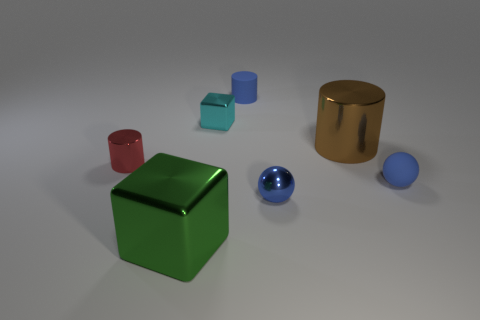What is the color of the tiny cylinder that is right of the block in front of the tiny metal sphere?
Offer a very short reply. Blue. What is the material of the blue object that is behind the small shiny cylinder?
Ensure brevity in your answer.  Rubber. Is the number of big gray matte balls less than the number of small red metallic cylinders?
Offer a terse response. Yes. There is a cyan thing; is its shape the same as the small blue thing that is behind the red metal cylinder?
Offer a very short reply. No. There is a object that is both behind the green object and on the left side of the cyan metallic cube; what shape is it?
Offer a very short reply. Cylinder. Is the number of tiny blue shiny things to the left of the blue cylinder the same as the number of tiny blue balls that are to the left of the cyan metallic thing?
Ensure brevity in your answer.  Yes. There is a small matte thing to the left of the large brown metal thing; is it the same shape as the tiny cyan thing?
Provide a short and direct response. No. What number of red things are matte objects or large blocks?
Ensure brevity in your answer.  0. There is another small thing that is the same shape as the tiny blue shiny thing; what is it made of?
Offer a terse response. Rubber. What is the shape of the object right of the large brown object?
Your response must be concise. Sphere. 